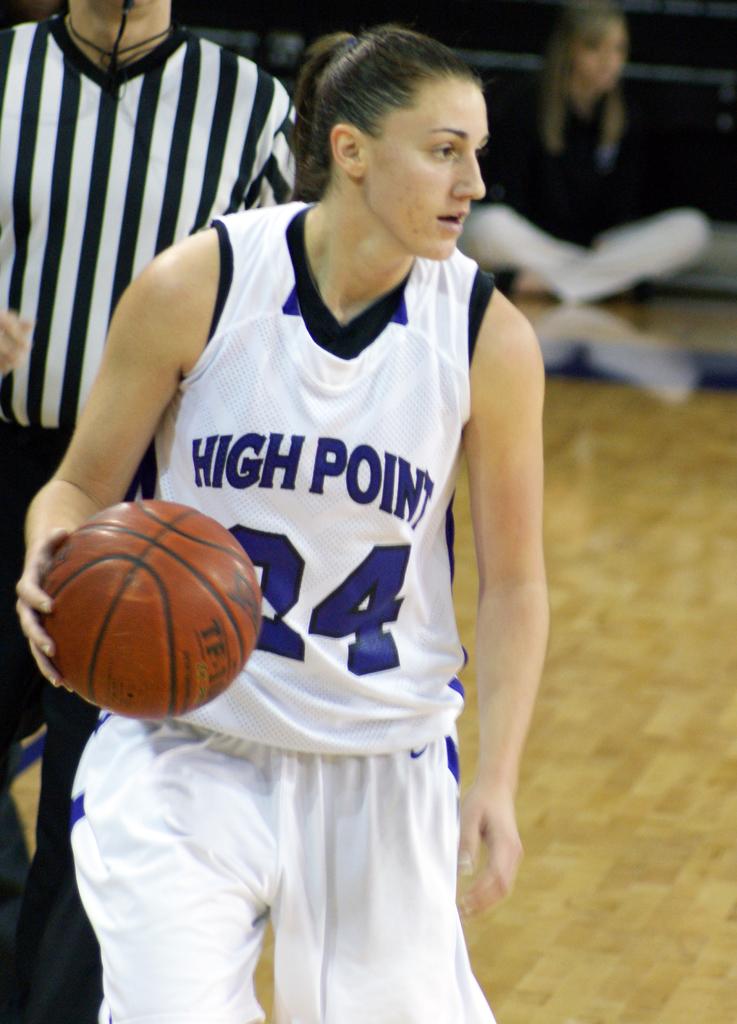What is the name of the school on the lady's jersey?
Your answer should be very brief. High point. What is the number under the word point?
Ensure brevity in your answer.  24. 